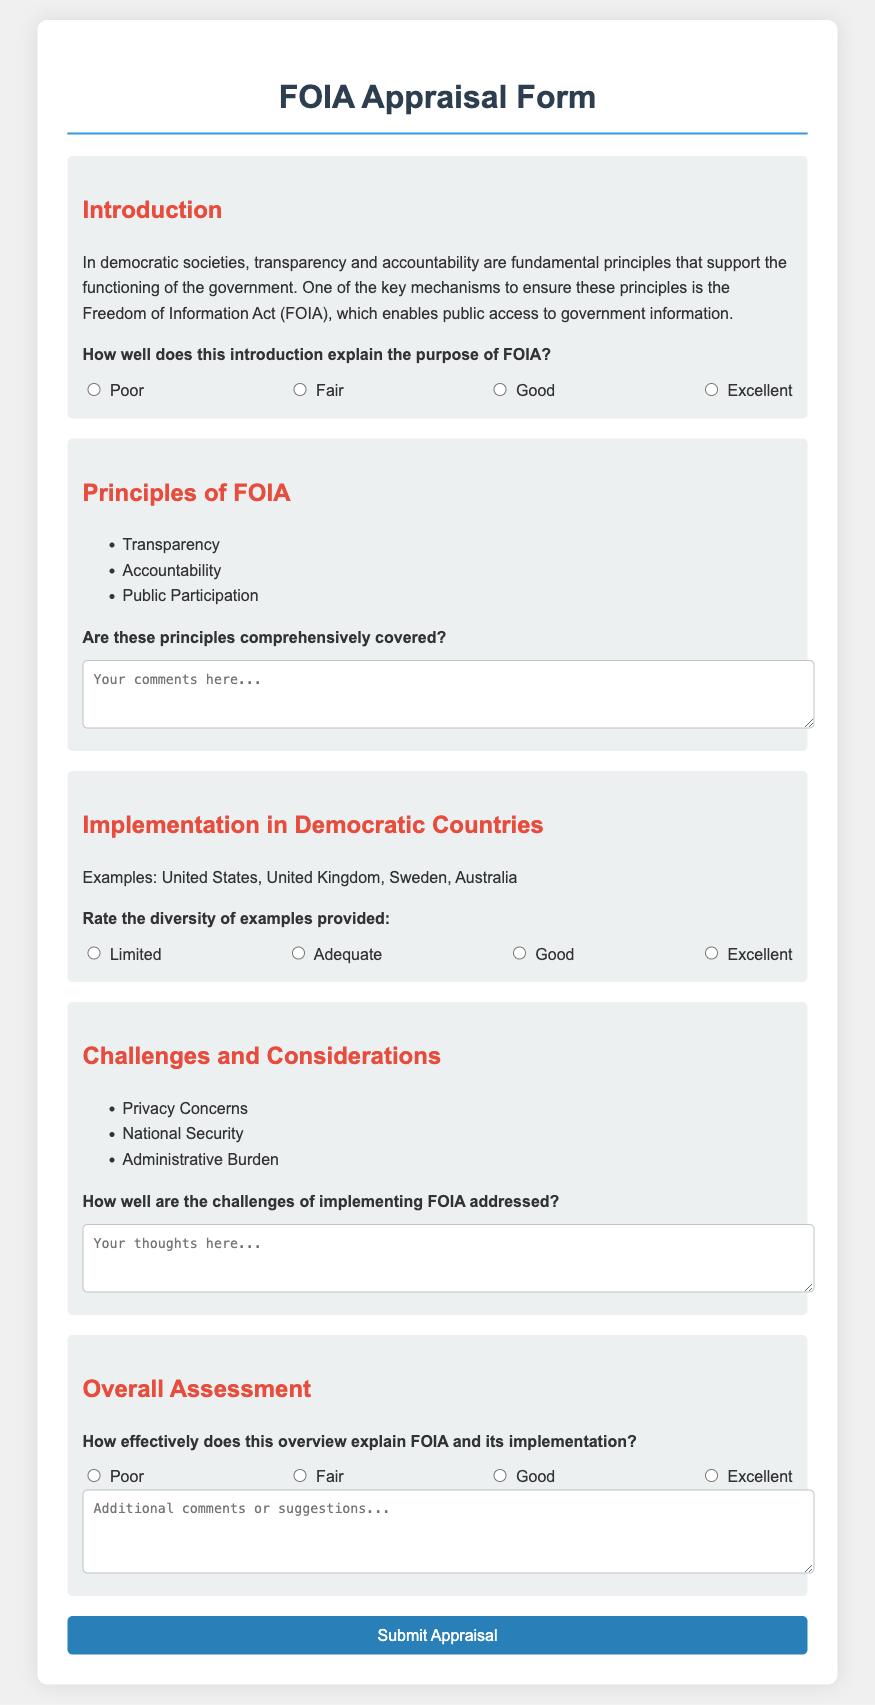What is the title of the document? The title is found in the head section of the HTML and describes the content of the document.
Answer: FOIA Appraisal Form What are the three main principles of FOIA outlined in the document? These principles are listed in the "Principles of FOIA" section.
Answer: Transparency, Accountability, Public Participation How many examples of countries with FOIA are mentioned? The document lists multiple countries in the implementation section.
Answer: Four What are the three challenges in implementing FOIA listed in the document? These challenges are provided in a list in the "Challenges and Considerations" section.
Answer: Privacy Concerns, National Security, Administrative Burden How is the effectiveness of the overview rated? The document includes a rating system to assess overall effectiveness.
Answer: Poor, Fair, Good, Excellent What feedback method is used for the introduction? The document uses a radio button selection method for users to give feedback on the introduction.
Answer: Radio buttons How are the comments collected in the "Principles of FOIA" section? The document provides a text area for users to write their comments on coverage of principles.
Answer: Text area How many sections are present in the appraisal form? The sections are counted based on the divisions outlined in the body of the document.
Answer: Five What color is used for headings in the document? The document specifies a color style for headings in the CSS.
Answer: Dark blue and red 